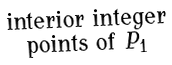<formula> <loc_0><loc_0><loc_500><loc_500>\begin{smallmatrix} \text {interior integer} \\ \text {points of } P _ { 1 } \end{smallmatrix}</formula> 